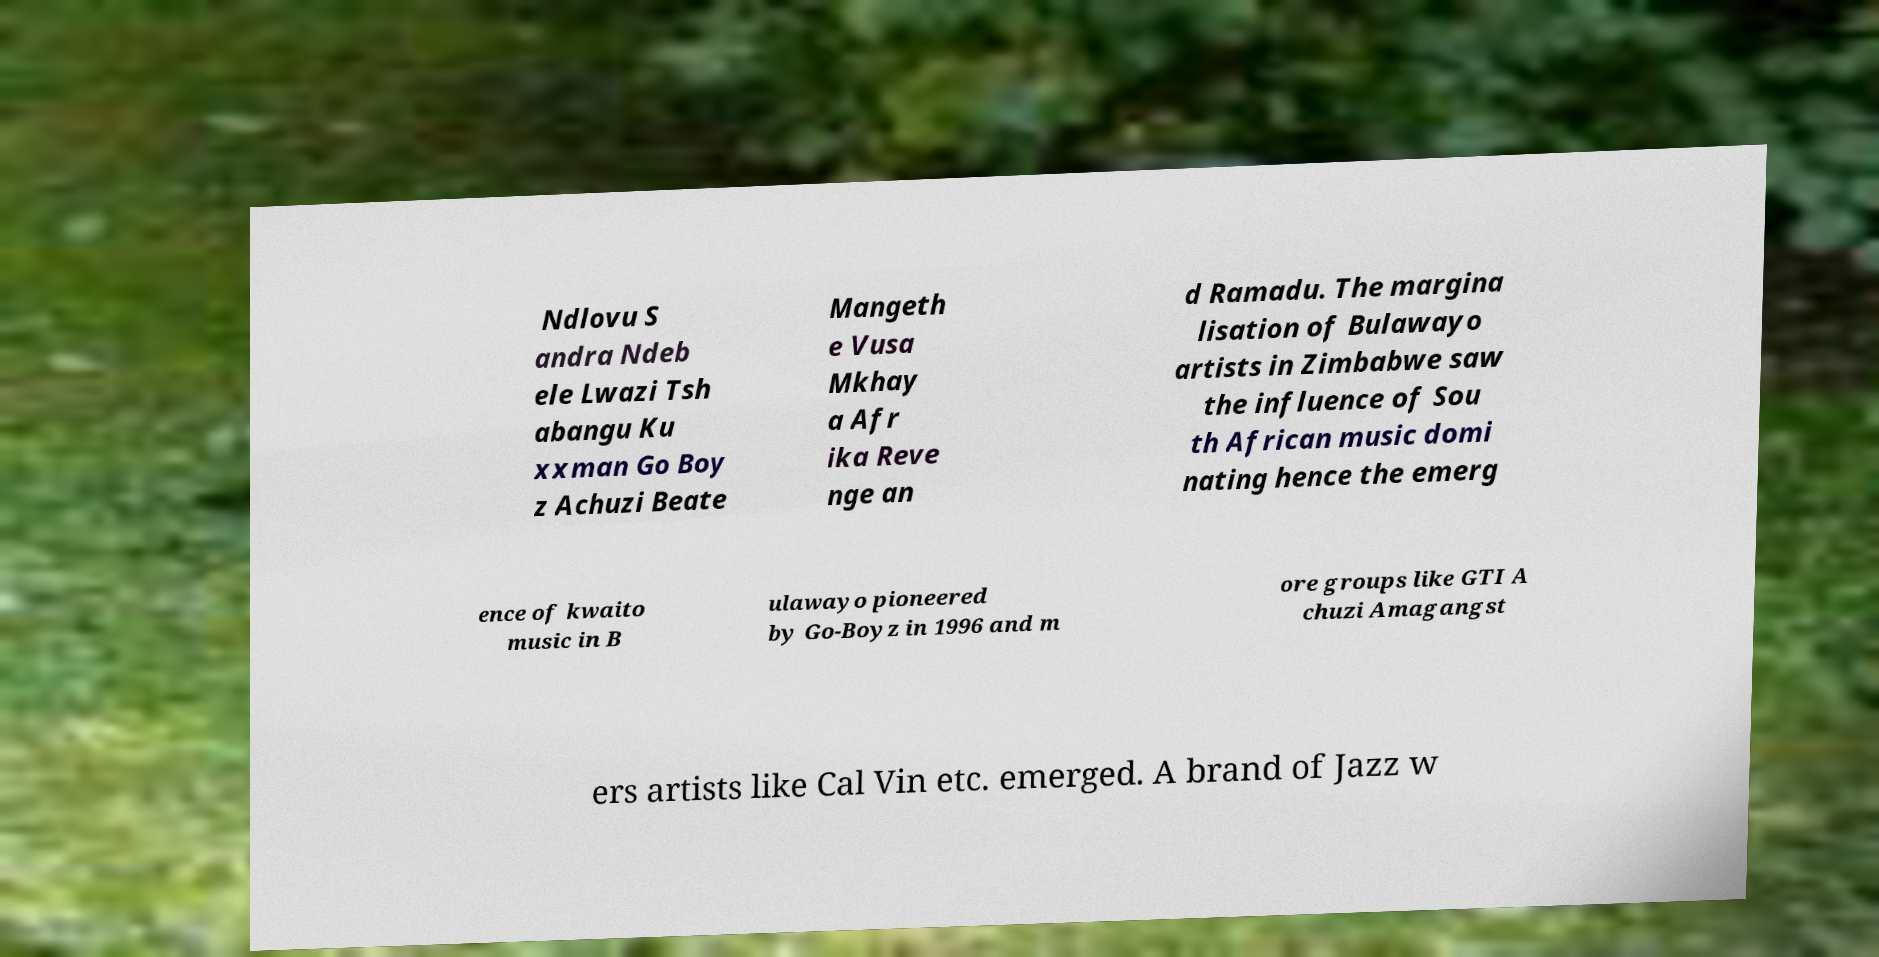Could you assist in decoding the text presented in this image and type it out clearly? Ndlovu S andra Ndeb ele Lwazi Tsh abangu Ku xxman Go Boy z Achuzi Beate Mangeth e Vusa Mkhay a Afr ika Reve nge an d Ramadu. The margina lisation of Bulawayo artists in Zimbabwe saw the influence of Sou th African music domi nating hence the emerg ence of kwaito music in B ulawayo pioneered by Go-Boyz in 1996 and m ore groups like GTI A chuzi Amagangst ers artists like Cal Vin etc. emerged. A brand of Jazz w 